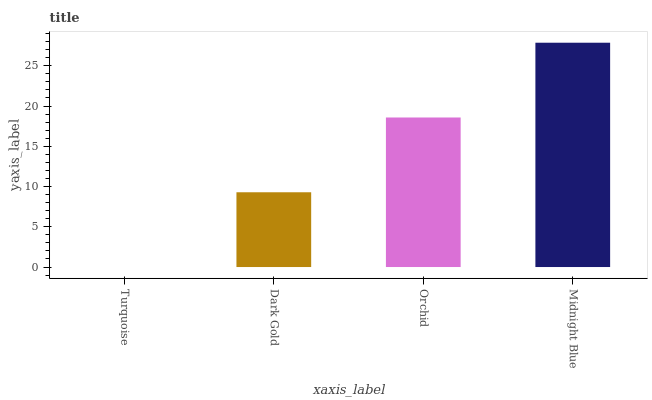Is Turquoise the minimum?
Answer yes or no. Yes. Is Midnight Blue the maximum?
Answer yes or no. Yes. Is Dark Gold the minimum?
Answer yes or no. No. Is Dark Gold the maximum?
Answer yes or no. No. Is Dark Gold greater than Turquoise?
Answer yes or no. Yes. Is Turquoise less than Dark Gold?
Answer yes or no. Yes. Is Turquoise greater than Dark Gold?
Answer yes or no. No. Is Dark Gold less than Turquoise?
Answer yes or no. No. Is Orchid the high median?
Answer yes or no. Yes. Is Dark Gold the low median?
Answer yes or no. Yes. Is Dark Gold the high median?
Answer yes or no. No. Is Turquoise the low median?
Answer yes or no. No. 